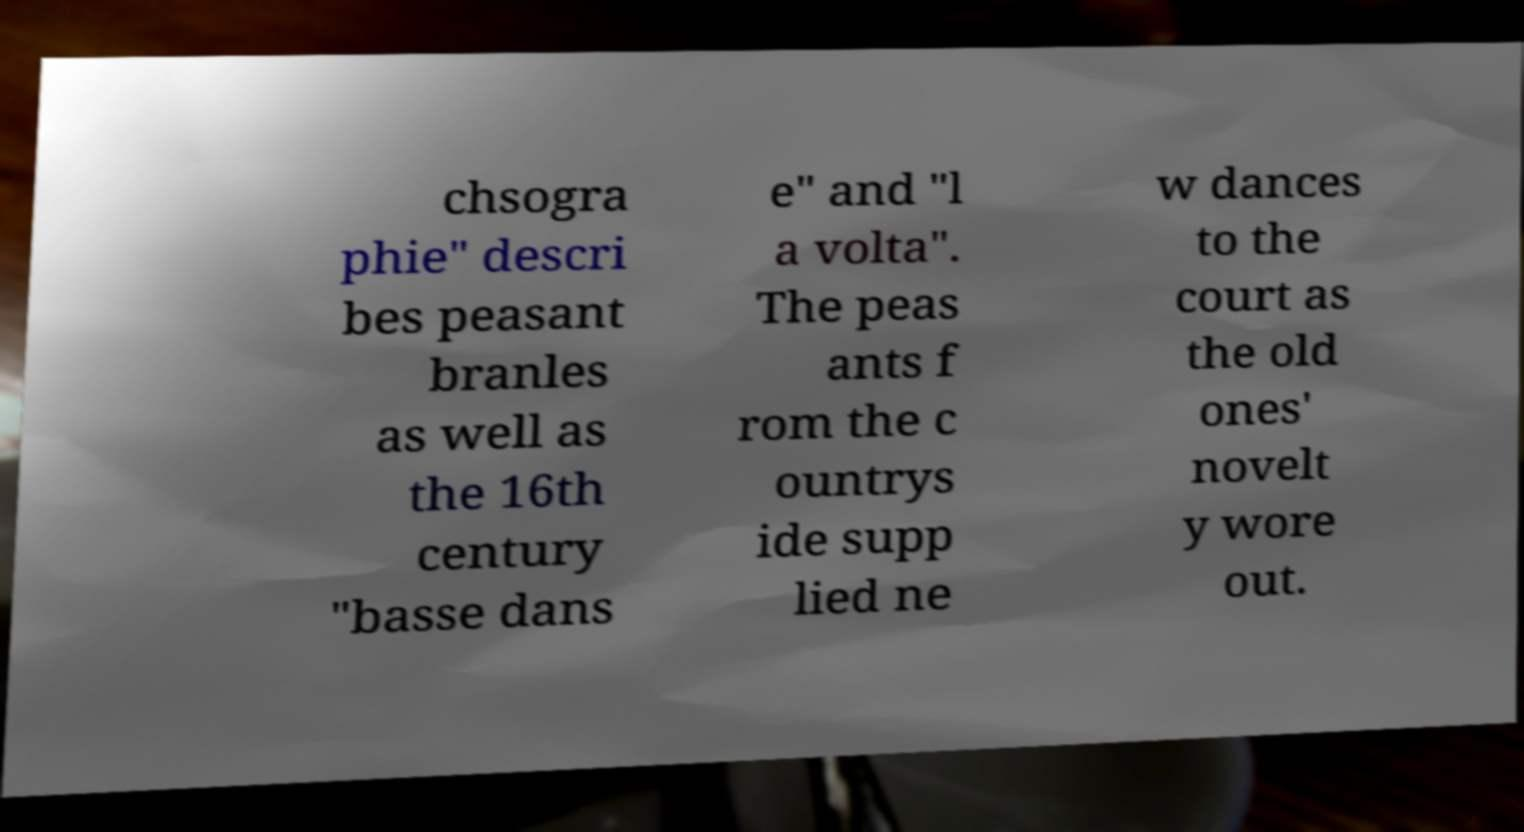Can you accurately transcribe the text from the provided image for me? chsogra phie" descri bes peasant branles as well as the 16th century "basse dans e" and "l a volta". The peas ants f rom the c ountrys ide supp lied ne w dances to the court as the old ones' novelt y wore out. 